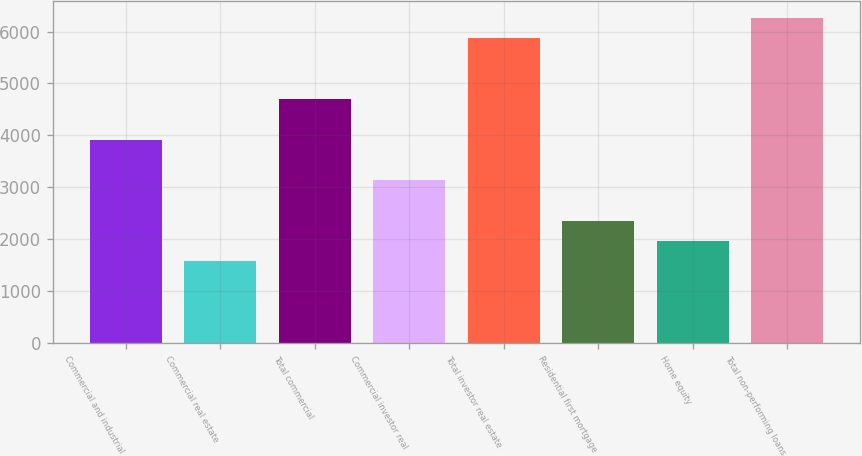Convert chart to OTSL. <chart><loc_0><loc_0><loc_500><loc_500><bar_chart><fcel>Commercial and industrial<fcel>Commercial real estate<fcel>Total commercial<fcel>Commercial investor real<fcel>Total investor real estate<fcel>Residential first mortgage<fcel>Home equity<fcel>Total non-performing loans<nl><fcel>3918<fcel>1568.4<fcel>4701.2<fcel>3134.8<fcel>5876<fcel>2351.6<fcel>1960<fcel>6267.6<nl></chart> 